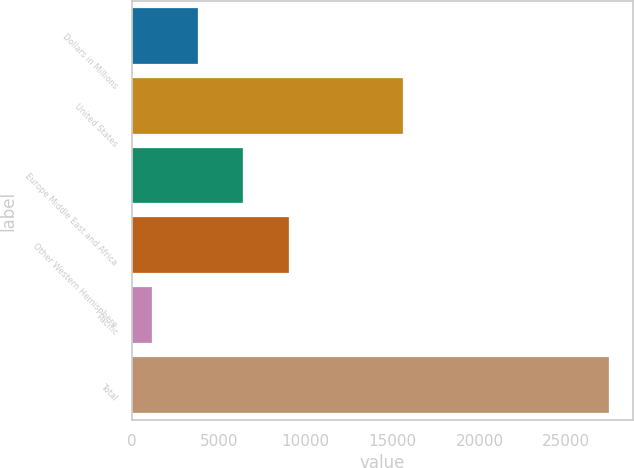Convert chart to OTSL. <chart><loc_0><loc_0><loc_500><loc_500><bar_chart><fcel>Dollars in Millions<fcel>United States<fcel>Europe Middle East and Africa<fcel>Other Western Hemisphere<fcel>Pacific<fcel>Total<nl><fcel>3773.5<fcel>15593<fcel>6404<fcel>9034.5<fcel>1143<fcel>27448<nl></chart> 